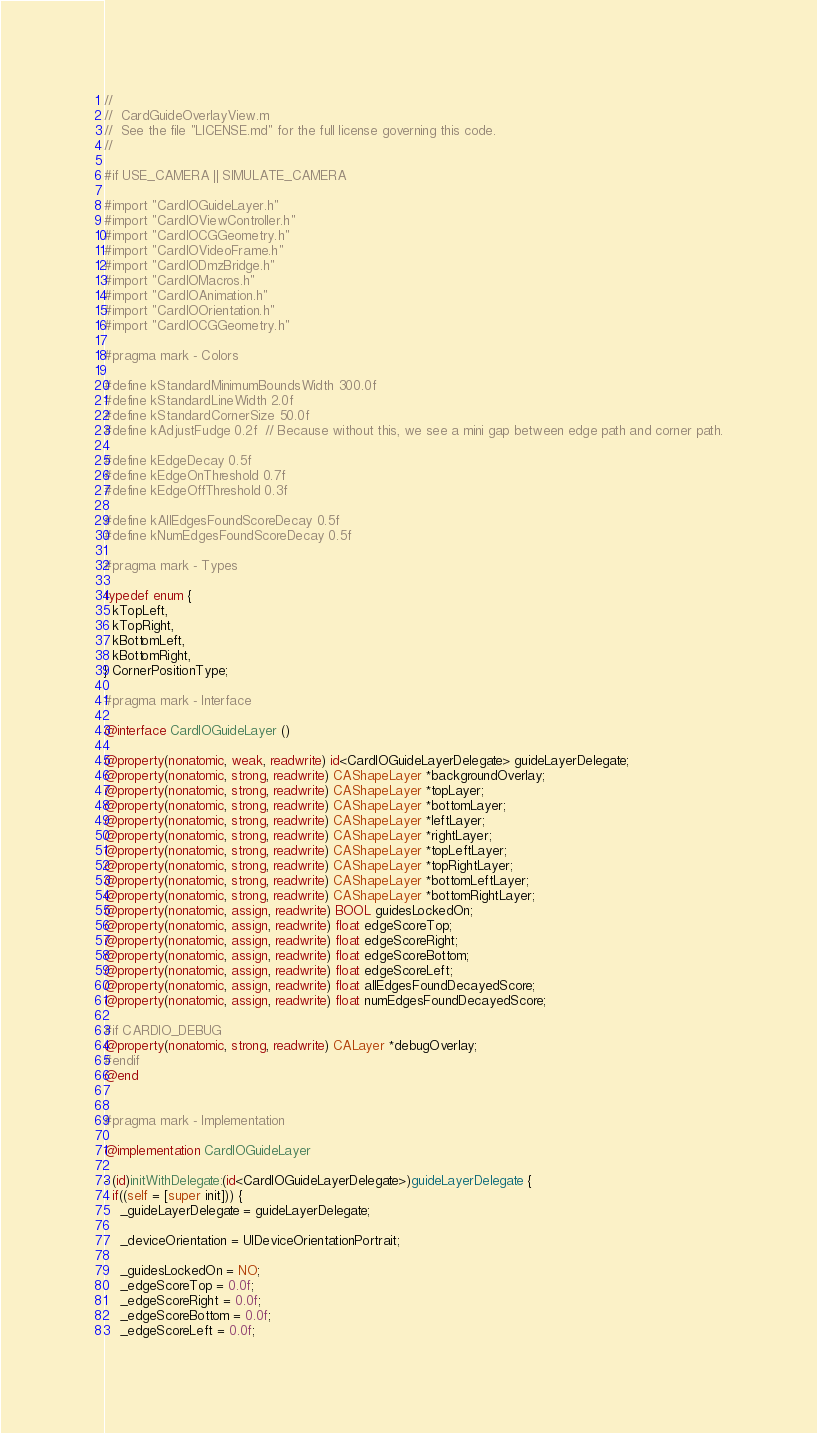Convert code to text. <code><loc_0><loc_0><loc_500><loc_500><_ObjectiveC_>//
//  CardGuideOverlayView.m
//  See the file "LICENSE.md" for the full license governing this code.
//

#if USE_CAMERA || SIMULATE_CAMERA

#import "CardIOGuideLayer.h"
#import "CardIOViewController.h"
#import "CardIOCGGeometry.h"
#import "CardIOVideoFrame.h"
#import "CardIODmzBridge.h"
#import "CardIOMacros.h"
#import "CardIOAnimation.h"
#import "CardIOOrientation.h"
#import "CardIOCGGeometry.h"

#pragma mark - Colors

#define kStandardMinimumBoundsWidth 300.0f
#define kStandardLineWidth 2.0f
#define kStandardCornerSize 50.0f
#define kAdjustFudge 0.2f  // Because without this, we see a mini gap between edge path and corner path.

#define kEdgeDecay 0.5f
#define kEdgeOnThreshold 0.7f
#define kEdgeOffThreshold 0.3f

#define kAllEdgesFoundScoreDecay 0.5f
#define kNumEdgesFoundScoreDecay 0.5f

#pragma mark - Types

typedef enum { 
  kTopLeft,
  kTopRight,
  kBottomLeft,
  kBottomRight,
} CornerPositionType;

#pragma mark - Interface

@interface CardIOGuideLayer ()

@property(nonatomic, weak, readwrite) id<CardIOGuideLayerDelegate> guideLayerDelegate;
@property(nonatomic, strong, readwrite) CAShapeLayer *backgroundOverlay;
@property(nonatomic, strong, readwrite) CAShapeLayer *topLayer;
@property(nonatomic, strong, readwrite) CAShapeLayer *bottomLayer;
@property(nonatomic, strong, readwrite) CAShapeLayer *leftLayer;
@property(nonatomic, strong, readwrite) CAShapeLayer *rightLayer;
@property(nonatomic, strong, readwrite) CAShapeLayer *topLeftLayer;
@property(nonatomic, strong, readwrite) CAShapeLayer *topRightLayer;
@property(nonatomic, strong, readwrite) CAShapeLayer *bottomLeftLayer;
@property(nonatomic, strong, readwrite) CAShapeLayer *bottomRightLayer;
@property(nonatomic, assign, readwrite) BOOL guidesLockedOn;
@property(nonatomic, assign, readwrite) float edgeScoreTop;
@property(nonatomic, assign, readwrite) float edgeScoreRight;
@property(nonatomic, assign, readwrite) float edgeScoreBottom;
@property(nonatomic, assign, readwrite) float edgeScoreLeft;
@property(nonatomic, assign, readwrite) float allEdgesFoundDecayedScore;
@property(nonatomic, assign, readwrite) float numEdgesFoundDecayedScore;

#if CARDIO_DEBUG
@property(nonatomic, strong, readwrite) CALayer *debugOverlay;
#endif
@end


#pragma mark - Implementation

@implementation CardIOGuideLayer

- (id)initWithDelegate:(id<CardIOGuideLayerDelegate>)guideLayerDelegate {
  if((self = [super init])) {
    _guideLayerDelegate = guideLayerDelegate;
    
    _deviceOrientation = UIDeviceOrientationPortrait;

    _guidesLockedOn = NO;
    _edgeScoreTop = 0.0f;
    _edgeScoreRight = 0.0f;
    _edgeScoreBottom = 0.0f;
    _edgeScoreLeft = 0.0f;
</code> 